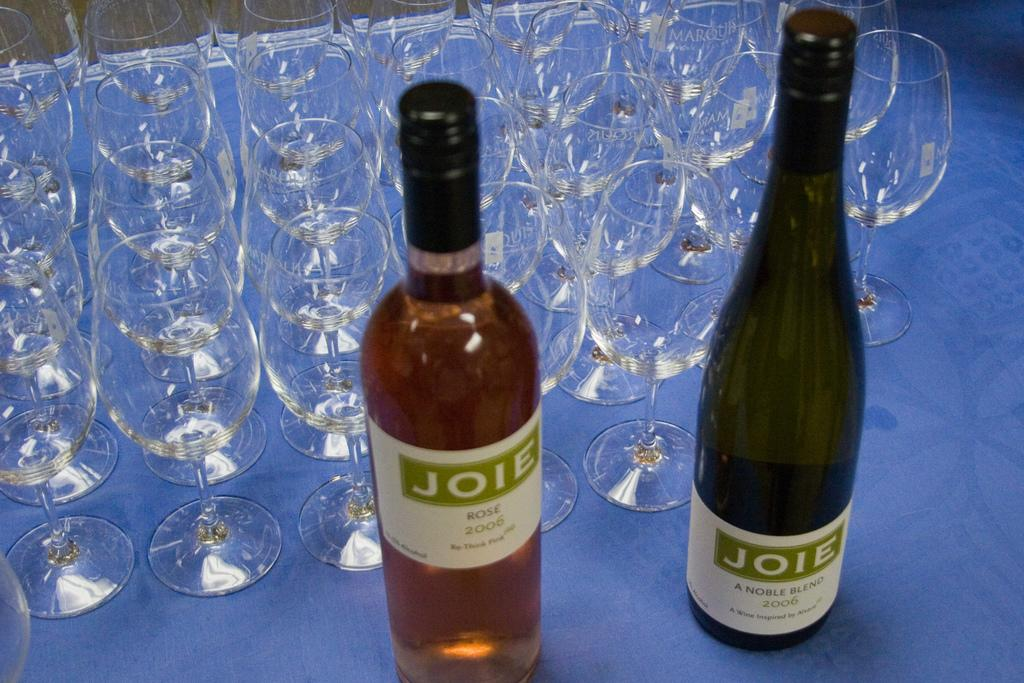<image>
Render a clear and concise summary of the photo. Empty glasses stand behind two bottles of Joie wines. 